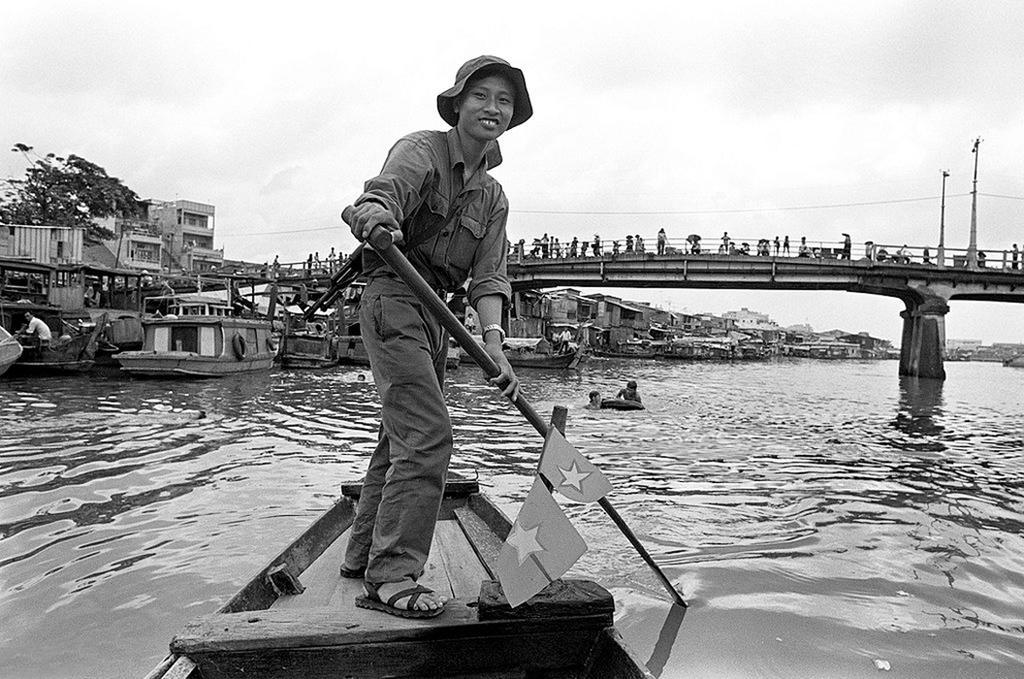How would you summarize this image in a sentence or two? In this image we can see a lady wearing cap, watch and gun. And she is holding a paddle and standing on a boat. And there is water. Also there are many boats on the water. And there is a bridge with pillar. And there are many people on the bridge. On the left side there is a tree. Also there are buildings. In the background there are buildings and sky. 